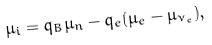Convert formula to latex. <formula><loc_0><loc_0><loc_500><loc_500>\mu _ { i } = q _ { B } \mu _ { n } - q _ { e } ( \mu _ { e } - \mu _ { \nu _ { e } } ) ,</formula> 